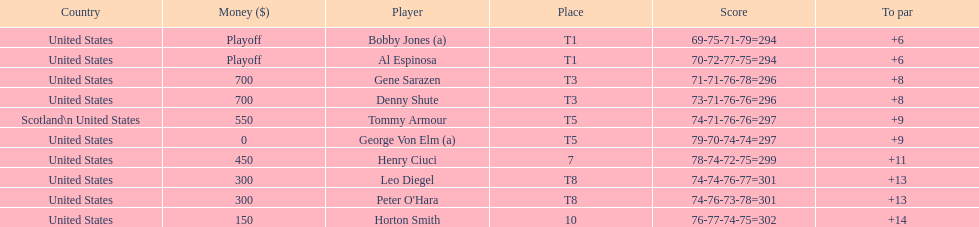Gene sarazen and denny shute are both from which country? United States. 